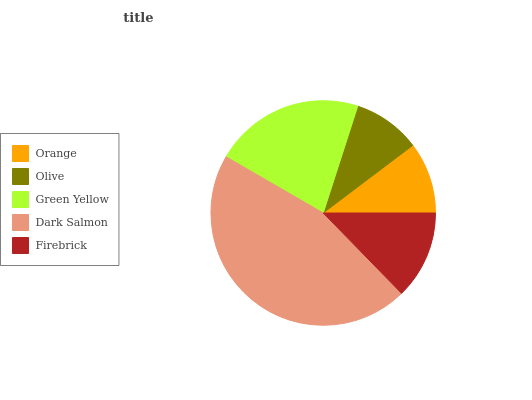Is Olive the minimum?
Answer yes or no. Yes. Is Dark Salmon the maximum?
Answer yes or no. Yes. Is Green Yellow the minimum?
Answer yes or no. No. Is Green Yellow the maximum?
Answer yes or no. No. Is Green Yellow greater than Olive?
Answer yes or no. Yes. Is Olive less than Green Yellow?
Answer yes or no. Yes. Is Olive greater than Green Yellow?
Answer yes or no. No. Is Green Yellow less than Olive?
Answer yes or no. No. Is Firebrick the high median?
Answer yes or no. Yes. Is Firebrick the low median?
Answer yes or no. Yes. Is Olive the high median?
Answer yes or no. No. Is Dark Salmon the low median?
Answer yes or no. No. 